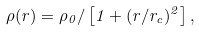Convert formula to latex. <formula><loc_0><loc_0><loc_500><loc_500>\rho ( r ) = \rho _ { 0 } / \left [ 1 + ( r / r _ { c } ) ^ { 2 } \right ] ,</formula> 